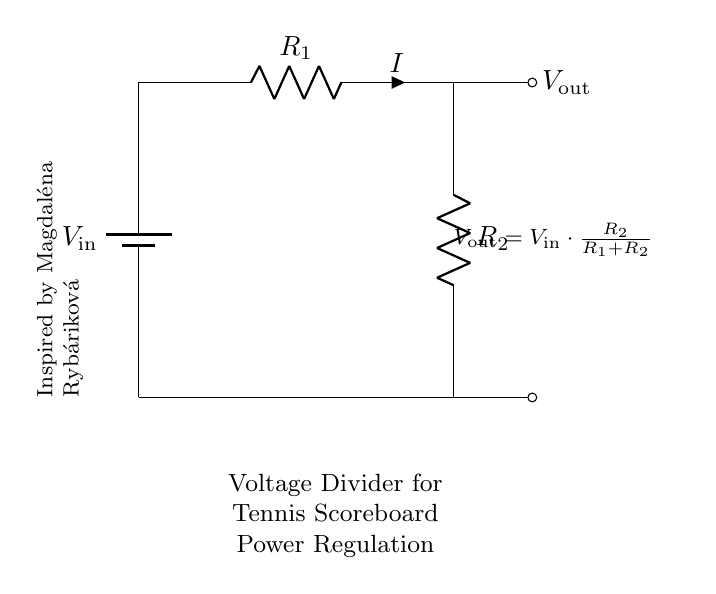What is the input voltage in this circuit? The input voltage is indicated as V_in labeled next to the battery symbol on the left side of the circuit diagram. It represents the total voltage supplied to the voltage divider circuit.
Answer: V_in What are the two resistors labeled in the circuit? The resistors in the circuit are labeled as R_1 and R_2 located in series. R_1 is on the top and R_2 is on the bottom, both of which are connected to the input voltage and ground.
Answer: R_1 and R_2 What is the formula used to calculate the output voltage? The formula for output voltage is labeled in the diagram, showing that V_out equals V_in multiplied by the ratio of R_2 to the sum of R_1 and R_2. This reflects the fundamental principle of how a voltage divider functions.
Answer: V_out = V_in * (R_2 / (R_1 + R_2)) What is the purpose of this circuit? The circuit is specifically designed for power regulation to electronic scoreboards on tennis courts. The output voltage can be adjusted to meet the required voltage for these devices while ensuring proper functionality.
Answer: Power regulation for scoreboards Which resistor receives the output voltage? The output voltage, V_out, is taken across the second resistor R_2 in the circuit. This means the potential difference is measured at the junction between R_1 and R_2.
Answer: R_2 How does changing R_2 affect V_out? Increasing the value of R_2 while keeping R_1 constant will increase V_out, as V_out is proportional to R_2 in the division formula. Conversely, decreasing R_2 reduces V_out. This demonstrates how adjusting resistor values directly influences the output of the divider.
Answer: Increases V_out 